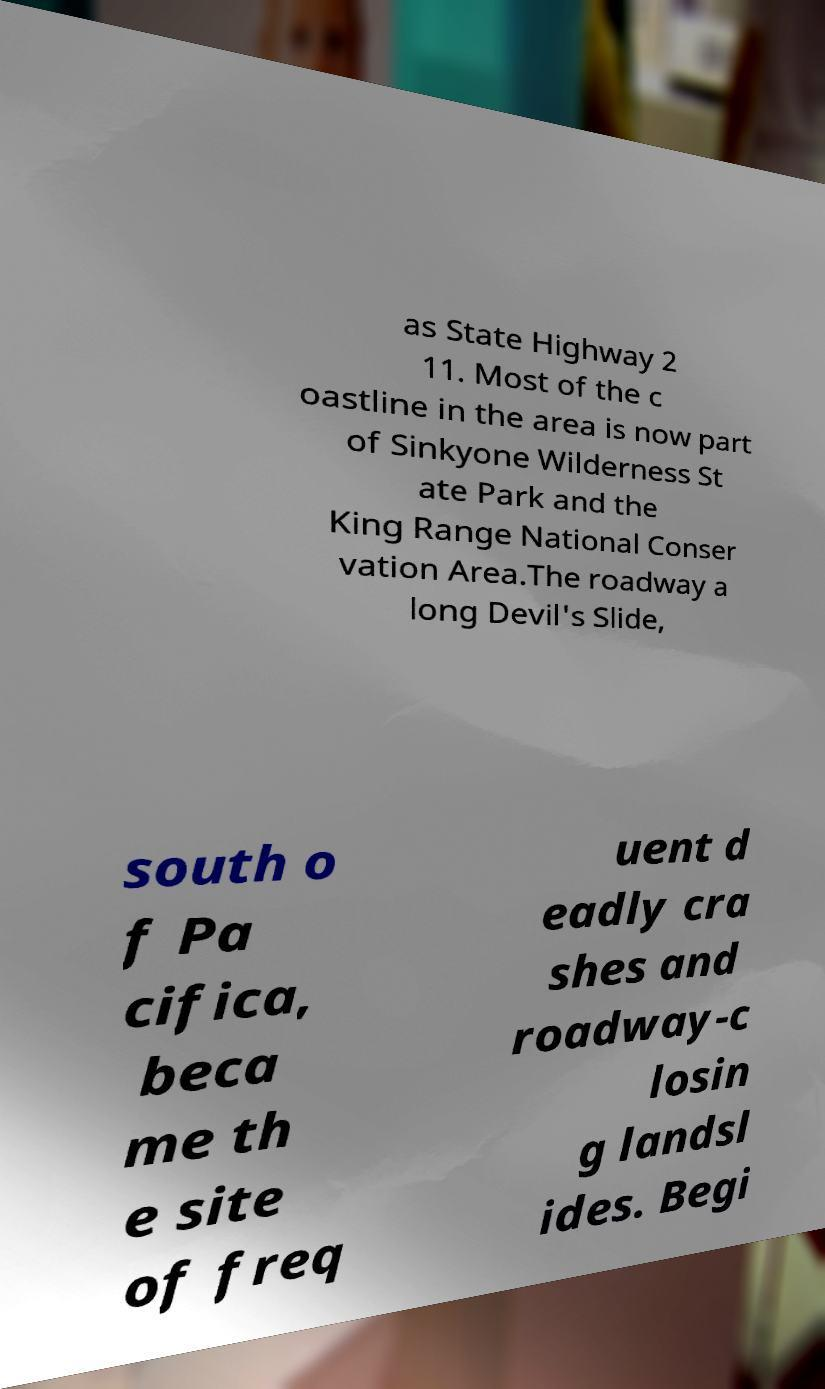For documentation purposes, I need the text within this image transcribed. Could you provide that? as State Highway 2 11. Most of the c oastline in the area is now part of Sinkyone Wilderness St ate Park and the King Range National Conser vation Area.The roadway a long Devil's Slide, south o f Pa cifica, beca me th e site of freq uent d eadly cra shes and roadway-c losin g landsl ides. Begi 